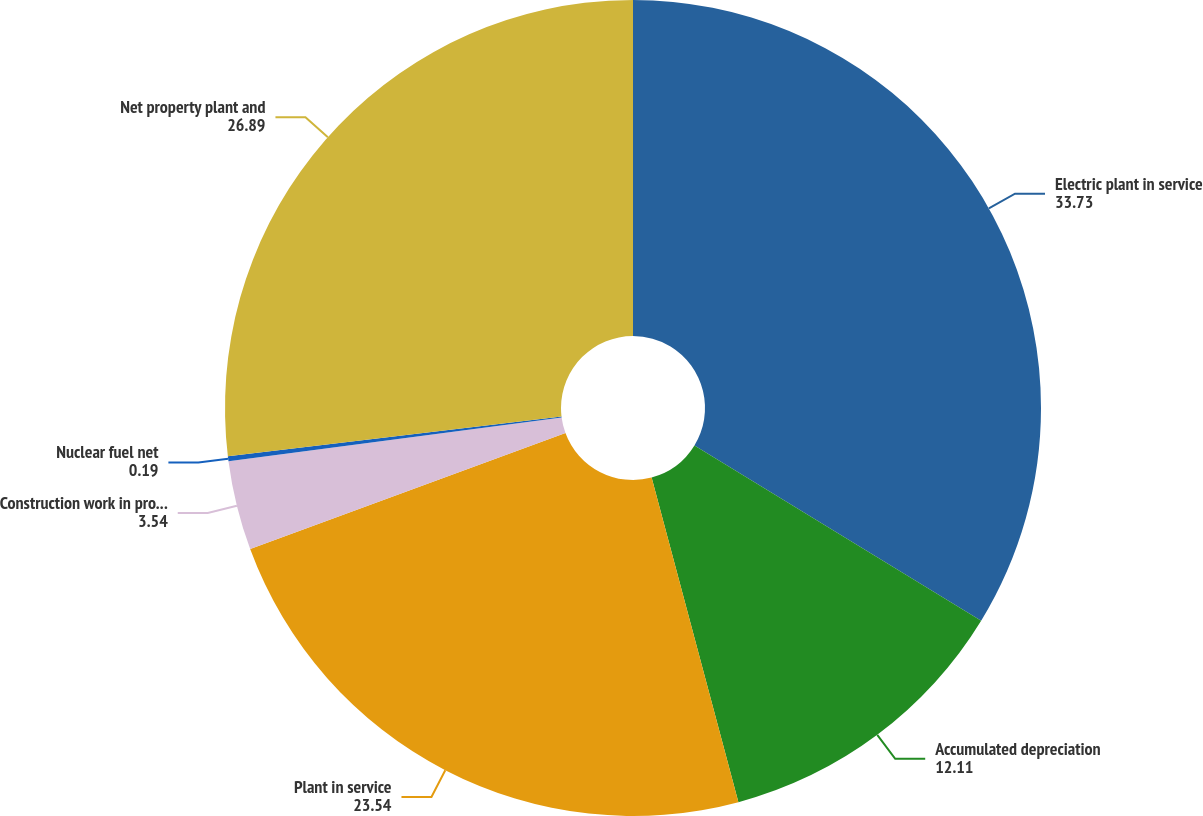<chart> <loc_0><loc_0><loc_500><loc_500><pie_chart><fcel>Electric plant in service<fcel>Accumulated depreciation<fcel>Plant in service<fcel>Construction work in progress<fcel>Nuclear fuel net<fcel>Net property plant and<nl><fcel>33.73%<fcel>12.11%<fcel>23.54%<fcel>3.54%<fcel>0.19%<fcel>26.89%<nl></chart> 